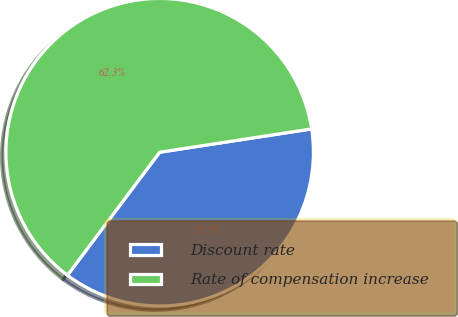<chart> <loc_0><loc_0><loc_500><loc_500><pie_chart><fcel>Discount rate<fcel>Rate of compensation increase<nl><fcel>37.66%<fcel>62.34%<nl></chart> 